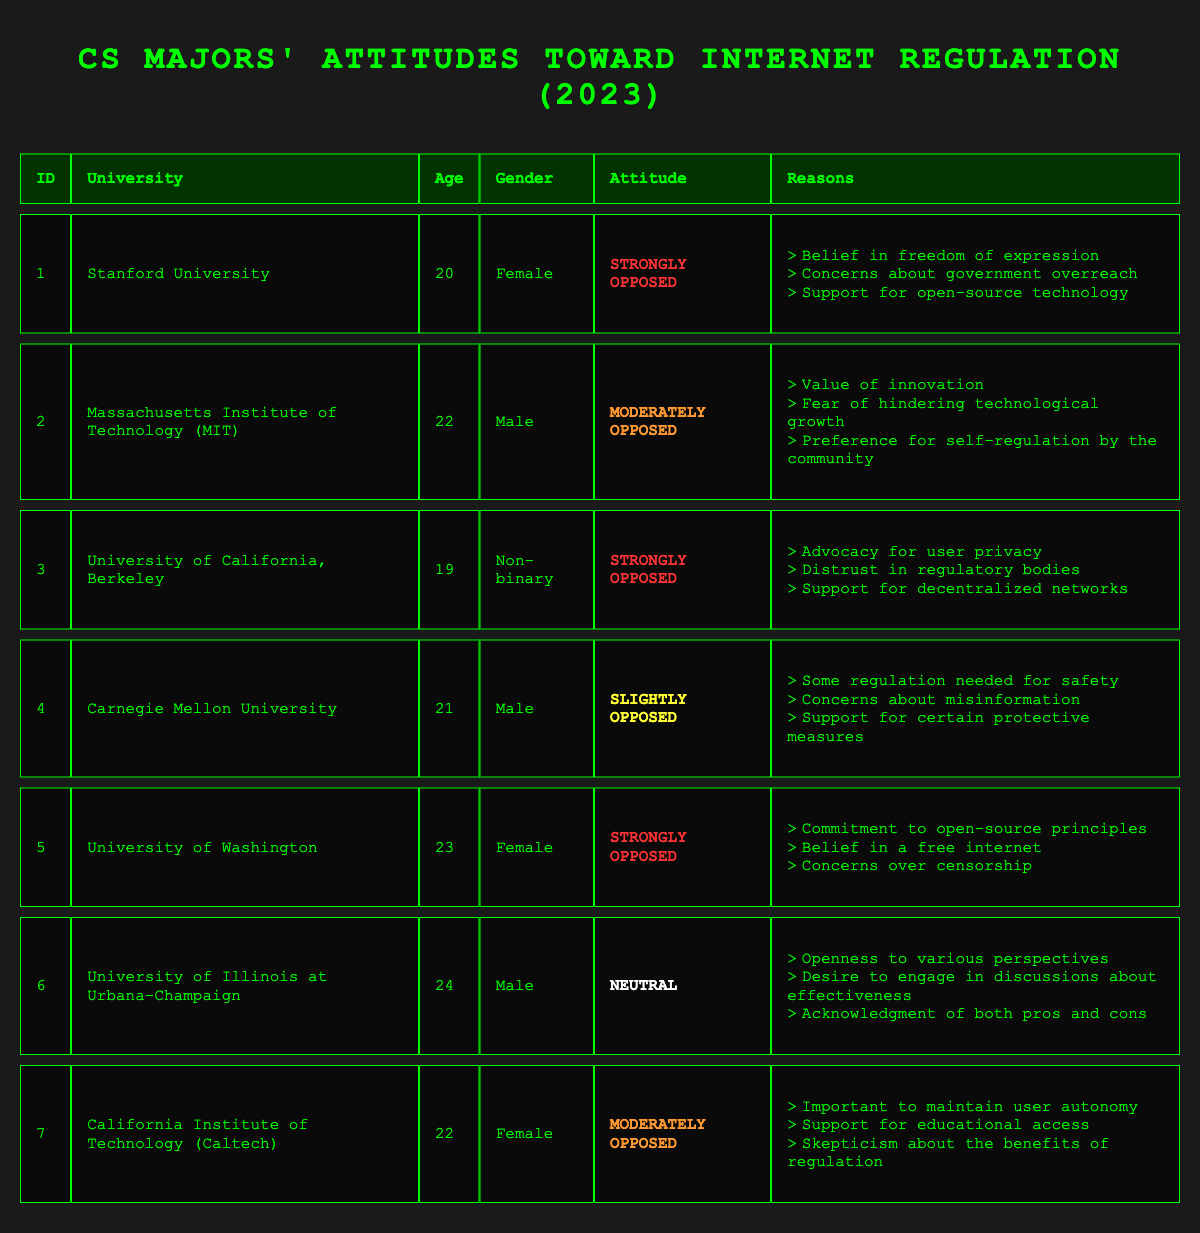What is the university with the youngest respondent? The youngest respondent is from the University of California, Berkeley, who is 19 years old. I find this by looking at the ages of all respondents listed in the table and identifying the minimum value.
Answer: University of California, Berkeley How many participants expressed being strongly opposed to internet regulation? There are three respondents who indicated that they are strongly opposed to internet regulation: those from Stanford University, the University of California, Berkeley, and the University of Washington. I count the rows where the attitude is marked as "Strongly Opposed."
Answer: 3 What is the average age of all respondents in this survey? The ages of the respondents are 20, 22, 19, 21, 23, 24, and 22. Adding these together gives a total of 151. Since there are 7 respondents, I divide 151 by 7 to find the average. The average age is approximately 21.57.
Answer: 21.57 Is there any respondent who is neutral about internet regulation? Yes, there is one respondent from the University of Illinois at Urbana-Champaign who indicated a neutral attitude toward internet regulation. I look through the attitudes column to confirm if any entry says "Neutral."
Answer: Yes Which university has a respondent that believes in self-regulation by the community? The Massachusetts Institute of Technology (MIT) has a respondent who stated the preference for self-regulation by the community as a reason for their moderately opposed stance. I check the reasons associated with that specific respondent to find that reference.
Answer: Massachusetts Institute of Technology (MIT) How many respondents are male and have a strong opposition to internet regulation? There are no male respondents who are strongly opposed to internet regulation. I verify each male respondent's attitude in the table and observe that both male respondents are either moderately or slightly opposed.
Answer: 0 Do any respondents express concerns about government overreach? Yes, there are two respondents who express concerns about government overreach. The respondents from Stanford University and the University of Washington both mentioned this in their reasons. I check the reasons list for each respondent to confirm these specific concerns.
Answer: Yes Which attitude is most common among the respondents? The most common attitude among the respondents is "Strongly Opposed," as it appears three times in the table. I count how many times each attitude appears and find that "Strongly Opposed" exceeds the others.
Answer: Strongly Opposed In total, how many reasons for attitudes against regulation are listed by the respondents? There are a total of 10 distinct reasons listed across all respondents. I count each unique reason in the reasons sections for all respondents, ensuring not to duplicate any that appear multiple times.
Answer: 10 